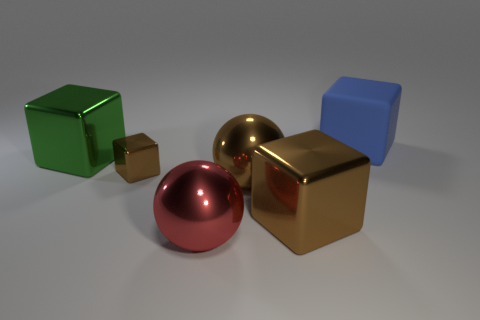Do the small block and the large metal sphere behind the big red thing have the same color?
Your answer should be very brief. Yes. Are there any other large things of the same shape as the red shiny object?
Provide a short and direct response. Yes. The large green object is what shape?
Offer a terse response. Cube. Is the number of big objects that are behind the red metallic thing greater than the number of large brown cubes that are behind the tiny brown metal thing?
Offer a terse response. Yes. How many other things are the same size as the red sphere?
Offer a terse response. 4. What material is the block that is on the right side of the red object and on the left side of the large blue object?
Provide a short and direct response. Metal. There is a brown object that is the same shape as the red object; what is its material?
Offer a very short reply. Metal. What number of red metallic things are left of the big brown thing that is to the left of the big metal block in front of the green object?
Give a very brief answer. 1. Is there anything else of the same color as the large matte object?
Give a very brief answer. No. How many big blocks are both left of the blue rubber cube and on the right side of the green cube?
Offer a terse response. 1. 